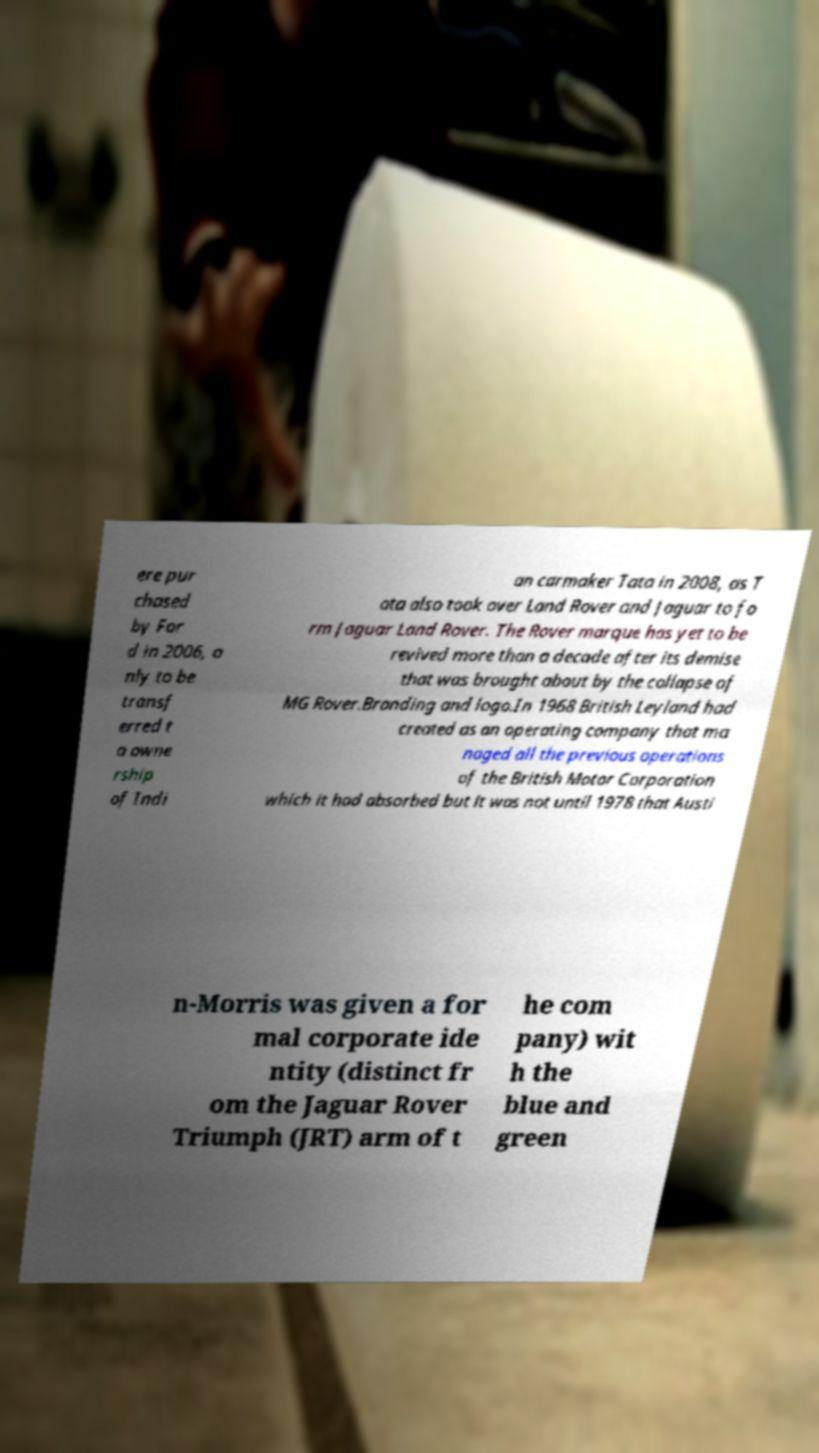Could you assist in decoding the text presented in this image and type it out clearly? ere pur chased by For d in 2006, o nly to be transf erred t o owne rship of Indi an carmaker Tata in 2008, as T ata also took over Land Rover and Jaguar to fo rm Jaguar Land Rover. The Rover marque has yet to be revived more than a decade after its demise that was brought about by the collapse of MG Rover.Branding and logo.In 1968 British Leyland had created as an operating company that ma naged all the previous operations of the British Motor Corporation which it had absorbed but it was not until 1978 that Austi n-Morris was given a for mal corporate ide ntity (distinct fr om the Jaguar Rover Triumph (JRT) arm of t he com pany) wit h the blue and green 